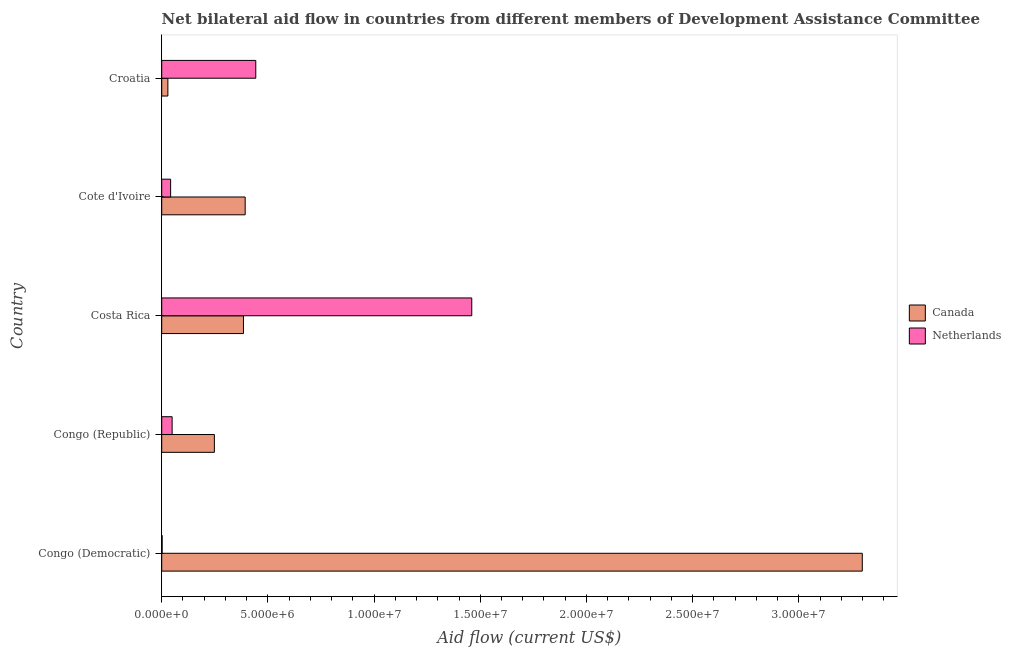How many different coloured bars are there?
Your answer should be compact. 2. How many groups of bars are there?
Offer a terse response. 5. How many bars are there on the 4th tick from the bottom?
Make the answer very short. 2. What is the label of the 4th group of bars from the top?
Your response must be concise. Congo (Republic). In how many cases, is the number of bars for a given country not equal to the number of legend labels?
Your answer should be compact. 0. What is the amount of aid given by netherlands in Congo (Republic)?
Give a very brief answer. 4.90e+05. Across all countries, what is the maximum amount of aid given by netherlands?
Ensure brevity in your answer.  1.46e+07. Across all countries, what is the minimum amount of aid given by canada?
Your answer should be compact. 2.90e+05. In which country was the amount of aid given by netherlands maximum?
Provide a short and direct response. Costa Rica. In which country was the amount of aid given by netherlands minimum?
Provide a succinct answer. Congo (Democratic). What is the total amount of aid given by canada in the graph?
Provide a short and direct response. 4.35e+07. What is the difference between the amount of aid given by canada in Costa Rica and that in Croatia?
Offer a terse response. 3.56e+06. What is the difference between the amount of aid given by canada in Cote d'Ivoire and the amount of aid given by netherlands in Congo (Republic)?
Provide a short and direct response. 3.44e+06. What is the average amount of aid given by canada per country?
Make the answer very short. 8.71e+06. What is the difference between the amount of aid given by netherlands and amount of aid given by canada in Cote d'Ivoire?
Your response must be concise. -3.51e+06. In how many countries, is the amount of aid given by canada greater than 23000000 US$?
Give a very brief answer. 1. What is the ratio of the amount of aid given by canada in Congo (Republic) to that in Cote d'Ivoire?
Your answer should be very brief. 0.63. Is the amount of aid given by netherlands in Congo (Democratic) less than that in Cote d'Ivoire?
Your response must be concise. Yes. What is the difference between the highest and the second highest amount of aid given by netherlands?
Provide a succinct answer. 1.02e+07. What is the difference between the highest and the lowest amount of aid given by netherlands?
Provide a short and direct response. 1.46e+07. In how many countries, is the amount of aid given by netherlands greater than the average amount of aid given by netherlands taken over all countries?
Provide a succinct answer. 2. What does the 1st bar from the bottom in Croatia represents?
Offer a terse response. Canada. How many bars are there?
Offer a very short reply. 10. Are all the bars in the graph horizontal?
Give a very brief answer. Yes. How many countries are there in the graph?
Offer a very short reply. 5. Does the graph contain any zero values?
Your answer should be compact. No. Does the graph contain grids?
Provide a short and direct response. No. Where does the legend appear in the graph?
Provide a succinct answer. Center right. How are the legend labels stacked?
Ensure brevity in your answer.  Vertical. What is the title of the graph?
Ensure brevity in your answer.  Net bilateral aid flow in countries from different members of Development Assistance Committee. What is the label or title of the X-axis?
Make the answer very short. Aid flow (current US$). What is the Aid flow (current US$) in Canada in Congo (Democratic)?
Provide a succinct answer. 3.30e+07. What is the Aid flow (current US$) in Netherlands in Congo (Democratic)?
Offer a terse response. 2.00e+04. What is the Aid flow (current US$) in Canada in Congo (Republic)?
Make the answer very short. 2.48e+06. What is the Aid flow (current US$) of Netherlands in Congo (Republic)?
Provide a succinct answer. 4.90e+05. What is the Aid flow (current US$) of Canada in Costa Rica?
Provide a short and direct response. 3.85e+06. What is the Aid flow (current US$) of Netherlands in Costa Rica?
Provide a succinct answer. 1.46e+07. What is the Aid flow (current US$) in Canada in Cote d'Ivoire?
Offer a terse response. 3.93e+06. What is the Aid flow (current US$) in Netherlands in Cote d'Ivoire?
Offer a terse response. 4.20e+05. What is the Aid flow (current US$) in Netherlands in Croatia?
Ensure brevity in your answer.  4.43e+06. Across all countries, what is the maximum Aid flow (current US$) in Canada?
Keep it short and to the point. 3.30e+07. Across all countries, what is the maximum Aid flow (current US$) of Netherlands?
Provide a succinct answer. 1.46e+07. Across all countries, what is the minimum Aid flow (current US$) in Canada?
Ensure brevity in your answer.  2.90e+05. Across all countries, what is the minimum Aid flow (current US$) of Netherlands?
Provide a succinct answer. 2.00e+04. What is the total Aid flow (current US$) of Canada in the graph?
Give a very brief answer. 4.35e+07. What is the total Aid flow (current US$) in Netherlands in the graph?
Offer a very short reply. 2.00e+07. What is the difference between the Aid flow (current US$) of Canada in Congo (Democratic) and that in Congo (Republic)?
Provide a succinct answer. 3.05e+07. What is the difference between the Aid flow (current US$) in Netherlands in Congo (Democratic) and that in Congo (Republic)?
Offer a terse response. -4.70e+05. What is the difference between the Aid flow (current US$) of Canada in Congo (Democratic) and that in Costa Rica?
Offer a very short reply. 2.91e+07. What is the difference between the Aid flow (current US$) of Netherlands in Congo (Democratic) and that in Costa Rica?
Offer a terse response. -1.46e+07. What is the difference between the Aid flow (current US$) of Canada in Congo (Democratic) and that in Cote d'Ivoire?
Provide a succinct answer. 2.91e+07. What is the difference between the Aid flow (current US$) in Netherlands in Congo (Democratic) and that in Cote d'Ivoire?
Your response must be concise. -4.00e+05. What is the difference between the Aid flow (current US$) of Canada in Congo (Democratic) and that in Croatia?
Offer a terse response. 3.27e+07. What is the difference between the Aid flow (current US$) in Netherlands in Congo (Democratic) and that in Croatia?
Ensure brevity in your answer.  -4.41e+06. What is the difference between the Aid flow (current US$) of Canada in Congo (Republic) and that in Costa Rica?
Ensure brevity in your answer.  -1.37e+06. What is the difference between the Aid flow (current US$) in Netherlands in Congo (Republic) and that in Costa Rica?
Provide a short and direct response. -1.41e+07. What is the difference between the Aid flow (current US$) in Canada in Congo (Republic) and that in Cote d'Ivoire?
Offer a very short reply. -1.45e+06. What is the difference between the Aid flow (current US$) of Netherlands in Congo (Republic) and that in Cote d'Ivoire?
Offer a very short reply. 7.00e+04. What is the difference between the Aid flow (current US$) in Canada in Congo (Republic) and that in Croatia?
Provide a succinct answer. 2.19e+06. What is the difference between the Aid flow (current US$) in Netherlands in Congo (Republic) and that in Croatia?
Provide a succinct answer. -3.94e+06. What is the difference between the Aid flow (current US$) of Canada in Costa Rica and that in Cote d'Ivoire?
Keep it short and to the point. -8.00e+04. What is the difference between the Aid flow (current US$) in Netherlands in Costa Rica and that in Cote d'Ivoire?
Make the answer very short. 1.42e+07. What is the difference between the Aid flow (current US$) of Canada in Costa Rica and that in Croatia?
Your answer should be very brief. 3.56e+06. What is the difference between the Aid flow (current US$) of Netherlands in Costa Rica and that in Croatia?
Your response must be concise. 1.02e+07. What is the difference between the Aid flow (current US$) in Canada in Cote d'Ivoire and that in Croatia?
Offer a terse response. 3.64e+06. What is the difference between the Aid flow (current US$) of Netherlands in Cote d'Ivoire and that in Croatia?
Offer a terse response. -4.01e+06. What is the difference between the Aid flow (current US$) in Canada in Congo (Democratic) and the Aid flow (current US$) in Netherlands in Congo (Republic)?
Keep it short and to the point. 3.25e+07. What is the difference between the Aid flow (current US$) of Canada in Congo (Democratic) and the Aid flow (current US$) of Netherlands in Costa Rica?
Provide a short and direct response. 1.84e+07. What is the difference between the Aid flow (current US$) of Canada in Congo (Democratic) and the Aid flow (current US$) of Netherlands in Cote d'Ivoire?
Give a very brief answer. 3.26e+07. What is the difference between the Aid flow (current US$) in Canada in Congo (Democratic) and the Aid flow (current US$) in Netherlands in Croatia?
Provide a short and direct response. 2.86e+07. What is the difference between the Aid flow (current US$) of Canada in Congo (Republic) and the Aid flow (current US$) of Netherlands in Costa Rica?
Offer a very short reply. -1.21e+07. What is the difference between the Aid flow (current US$) in Canada in Congo (Republic) and the Aid flow (current US$) in Netherlands in Cote d'Ivoire?
Your response must be concise. 2.06e+06. What is the difference between the Aid flow (current US$) in Canada in Congo (Republic) and the Aid flow (current US$) in Netherlands in Croatia?
Ensure brevity in your answer.  -1.95e+06. What is the difference between the Aid flow (current US$) in Canada in Costa Rica and the Aid flow (current US$) in Netherlands in Cote d'Ivoire?
Give a very brief answer. 3.43e+06. What is the difference between the Aid flow (current US$) of Canada in Costa Rica and the Aid flow (current US$) of Netherlands in Croatia?
Provide a succinct answer. -5.80e+05. What is the difference between the Aid flow (current US$) in Canada in Cote d'Ivoire and the Aid flow (current US$) in Netherlands in Croatia?
Your response must be concise. -5.00e+05. What is the average Aid flow (current US$) of Canada per country?
Provide a succinct answer. 8.71e+06. What is the average Aid flow (current US$) of Netherlands per country?
Provide a short and direct response. 3.99e+06. What is the difference between the Aid flow (current US$) of Canada and Aid flow (current US$) of Netherlands in Congo (Democratic)?
Give a very brief answer. 3.30e+07. What is the difference between the Aid flow (current US$) of Canada and Aid flow (current US$) of Netherlands in Congo (Republic)?
Keep it short and to the point. 1.99e+06. What is the difference between the Aid flow (current US$) of Canada and Aid flow (current US$) of Netherlands in Costa Rica?
Give a very brief answer. -1.08e+07. What is the difference between the Aid flow (current US$) in Canada and Aid flow (current US$) in Netherlands in Cote d'Ivoire?
Your answer should be compact. 3.51e+06. What is the difference between the Aid flow (current US$) in Canada and Aid flow (current US$) in Netherlands in Croatia?
Provide a short and direct response. -4.14e+06. What is the ratio of the Aid flow (current US$) in Canada in Congo (Democratic) to that in Congo (Republic)?
Keep it short and to the point. 13.3. What is the ratio of the Aid flow (current US$) of Netherlands in Congo (Democratic) to that in Congo (Republic)?
Keep it short and to the point. 0.04. What is the ratio of the Aid flow (current US$) of Canada in Congo (Democratic) to that in Costa Rica?
Your answer should be very brief. 8.57. What is the ratio of the Aid flow (current US$) in Netherlands in Congo (Democratic) to that in Costa Rica?
Offer a very short reply. 0. What is the ratio of the Aid flow (current US$) in Canada in Congo (Democratic) to that in Cote d'Ivoire?
Keep it short and to the point. 8.39. What is the ratio of the Aid flow (current US$) in Netherlands in Congo (Democratic) to that in Cote d'Ivoire?
Offer a very short reply. 0.05. What is the ratio of the Aid flow (current US$) in Canada in Congo (Democratic) to that in Croatia?
Provide a short and direct response. 113.76. What is the ratio of the Aid flow (current US$) in Netherlands in Congo (Democratic) to that in Croatia?
Offer a terse response. 0. What is the ratio of the Aid flow (current US$) in Canada in Congo (Republic) to that in Costa Rica?
Keep it short and to the point. 0.64. What is the ratio of the Aid flow (current US$) of Netherlands in Congo (Republic) to that in Costa Rica?
Make the answer very short. 0.03. What is the ratio of the Aid flow (current US$) of Canada in Congo (Republic) to that in Cote d'Ivoire?
Your answer should be very brief. 0.63. What is the ratio of the Aid flow (current US$) of Canada in Congo (Republic) to that in Croatia?
Offer a terse response. 8.55. What is the ratio of the Aid flow (current US$) of Netherlands in Congo (Republic) to that in Croatia?
Provide a short and direct response. 0.11. What is the ratio of the Aid flow (current US$) in Canada in Costa Rica to that in Cote d'Ivoire?
Provide a succinct answer. 0.98. What is the ratio of the Aid flow (current US$) of Netherlands in Costa Rica to that in Cote d'Ivoire?
Provide a succinct answer. 34.76. What is the ratio of the Aid flow (current US$) in Canada in Costa Rica to that in Croatia?
Offer a very short reply. 13.28. What is the ratio of the Aid flow (current US$) of Netherlands in Costa Rica to that in Croatia?
Make the answer very short. 3.3. What is the ratio of the Aid flow (current US$) of Canada in Cote d'Ivoire to that in Croatia?
Offer a very short reply. 13.55. What is the ratio of the Aid flow (current US$) of Netherlands in Cote d'Ivoire to that in Croatia?
Your answer should be compact. 0.09. What is the difference between the highest and the second highest Aid flow (current US$) of Canada?
Keep it short and to the point. 2.91e+07. What is the difference between the highest and the second highest Aid flow (current US$) in Netherlands?
Give a very brief answer. 1.02e+07. What is the difference between the highest and the lowest Aid flow (current US$) of Canada?
Ensure brevity in your answer.  3.27e+07. What is the difference between the highest and the lowest Aid flow (current US$) of Netherlands?
Give a very brief answer. 1.46e+07. 